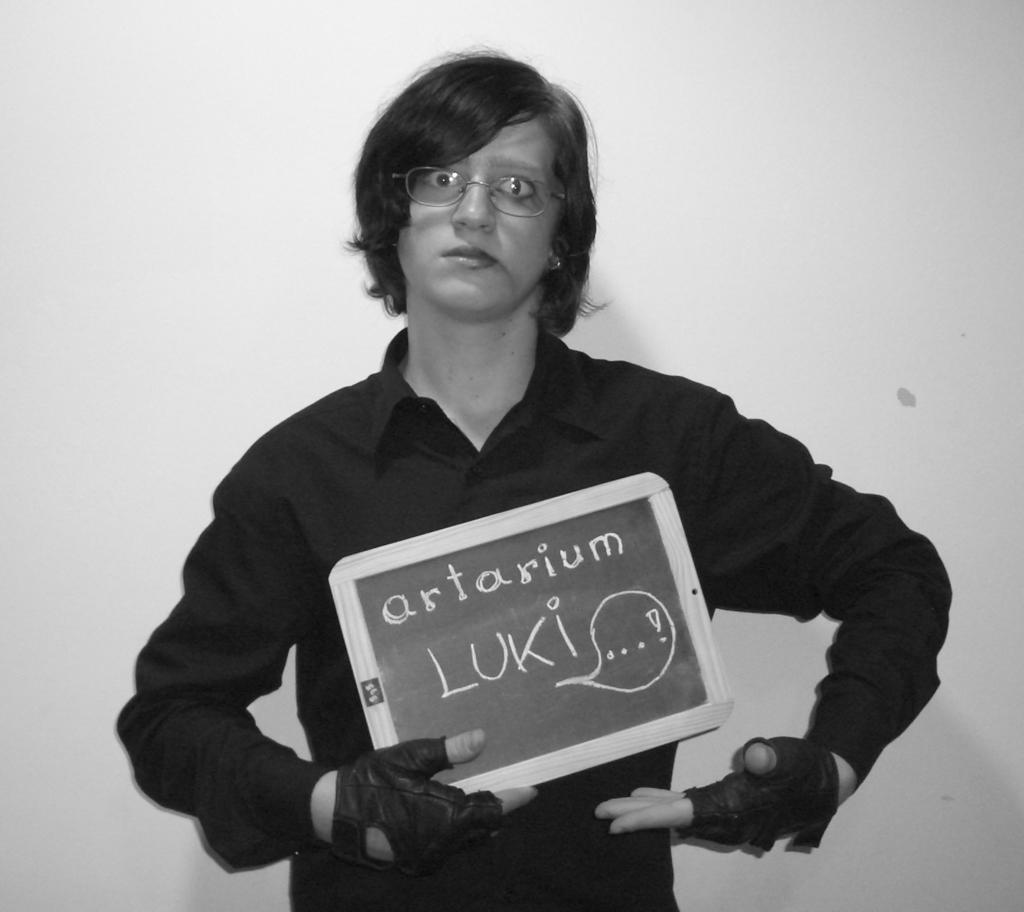Describe this image in one or two sentences. In this image there is a person standing and holding a slate board, and in the background there is a wall. 